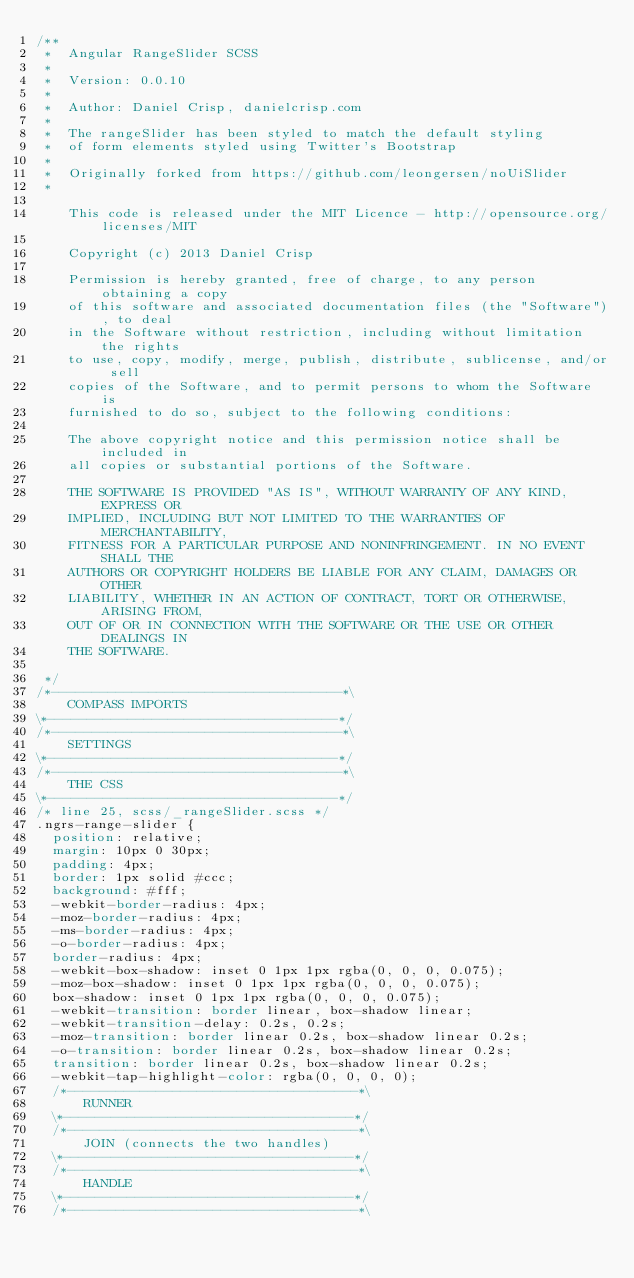Convert code to text. <code><loc_0><loc_0><loc_500><loc_500><_CSS_>/**
 * 	Angular RangeSlider SCSS
 * 
 *	Version: 0.0.10
 *
 * 	Author: Daniel Crisp, danielcrisp.com
 *
 * 	The rangeSlider has been styled to match the default styling
 * 	of form elements styled using Twitter's Bootstrap
 * 
 * 	Originally forked from https://github.com/leongersen/noUiSlider
 *

	This code is released under the MIT Licence - http://opensource.org/licenses/MIT

	Copyright (c) 2013 Daniel Crisp

	Permission is hereby granted, free of charge, to any person obtaining a copy
	of this software and associated documentation files (the "Software"), to deal
	in the Software without restriction, including without limitation the rights
	to use, copy, modify, merge, publish, distribute, sublicense, and/or sell
	copies of the Software, and to permit persons to whom the Software is
	furnished to do so, subject to the following conditions:

	The above copyright notice and this permission notice shall be included in
	all copies or substantial portions of the Software.

	THE SOFTWARE IS PROVIDED "AS IS", WITHOUT WARRANTY OF ANY KIND, EXPRESS OR
	IMPLIED, INCLUDING BUT NOT LIMITED TO THE WARRANTIES OF MERCHANTABILITY,
	FITNESS FOR A PARTICULAR PURPOSE AND NONINFRINGEMENT. IN NO EVENT SHALL THE
	AUTHORS OR COPYRIGHT HOLDERS BE LIABLE FOR ANY CLAIM, DAMAGES OR OTHER
	LIABILITY, WHETHER IN AN ACTION OF CONTRACT, TORT OR OTHERWISE, ARISING FROM,
	OUT OF OR IN CONNECTION WITH THE SOFTWARE OR THE USE OR OTHER DEALINGS IN
	THE SOFTWARE.

 */
/*------------------------------------*\
    COMPASS IMPORTS
\*------------------------------------*/
/*------------------------------------*\
    SETTINGS
\*------------------------------------*/
/*------------------------------------*\
    THE CSS
\*------------------------------------*/
/* line 25, scss/_rangeSlider.scss */
.ngrs-range-slider {
  position: relative;
  margin: 10px 0 30px;
  padding: 4px;
  border: 1px solid #ccc;
  background: #fff;
  -webkit-border-radius: 4px;
  -moz-border-radius: 4px;
  -ms-border-radius: 4px;
  -o-border-radius: 4px;
  border-radius: 4px;
  -webkit-box-shadow: inset 0 1px 1px rgba(0, 0, 0, 0.075);
  -moz-box-shadow: inset 0 1px 1px rgba(0, 0, 0, 0.075);
  box-shadow: inset 0 1px 1px rgba(0, 0, 0, 0.075);
  -webkit-transition: border linear, box-shadow linear;
  -webkit-transition-delay: 0.2s, 0.2s;
  -moz-transition: border linear 0.2s, box-shadow linear 0.2s;
  -o-transition: border linear 0.2s, box-shadow linear 0.2s;
  transition: border linear 0.2s, box-shadow linear 0.2s;
  -webkit-tap-highlight-color: rgba(0, 0, 0, 0);
  /*------------------------------------*\
      RUNNER
  \*------------------------------------*/
  /*------------------------------------*\
      JOIN (connects the two handles)
  \*------------------------------------*/
  /*------------------------------------*\
      HANDLE
  \*------------------------------------*/
  /*------------------------------------*\</code> 